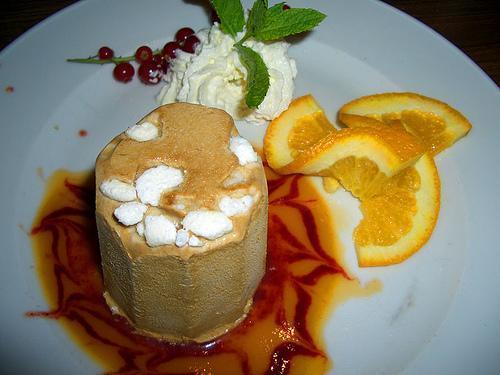How many oranges are there?
Give a very brief answer. 3. 